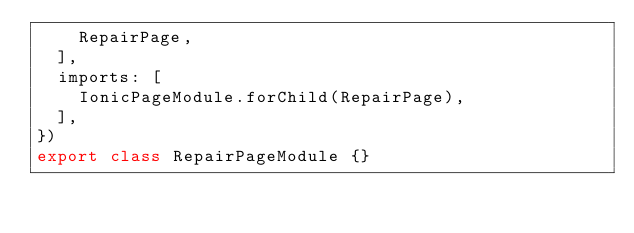Convert code to text. <code><loc_0><loc_0><loc_500><loc_500><_TypeScript_>    RepairPage,
  ],
  imports: [
    IonicPageModule.forChild(RepairPage),
  ],
})
export class RepairPageModule {}
</code> 